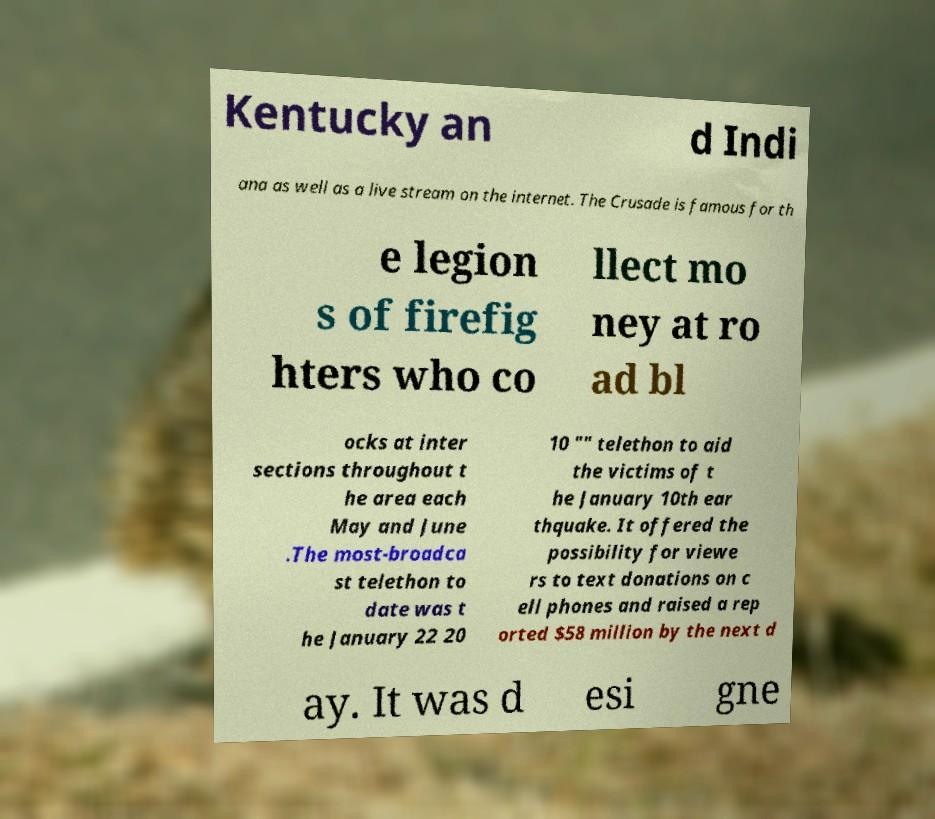Could you extract and type out the text from this image? Kentucky an d Indi ana as well as a live stream on the internet. The Crusade is famous for th e legion s of firefig hters who co llect mo ney at ro ad bl ocks at inter sections throughout t he area each May and June .The most-broadca st telethon to date was t he January 22 20 10 "" telethon to aid the victims of t he January 10th ear thquake. It offered the possibility for viewe rs to text donations on c ell phones and raised a rep orted $58 million by the next d ay. It was d esi gne 